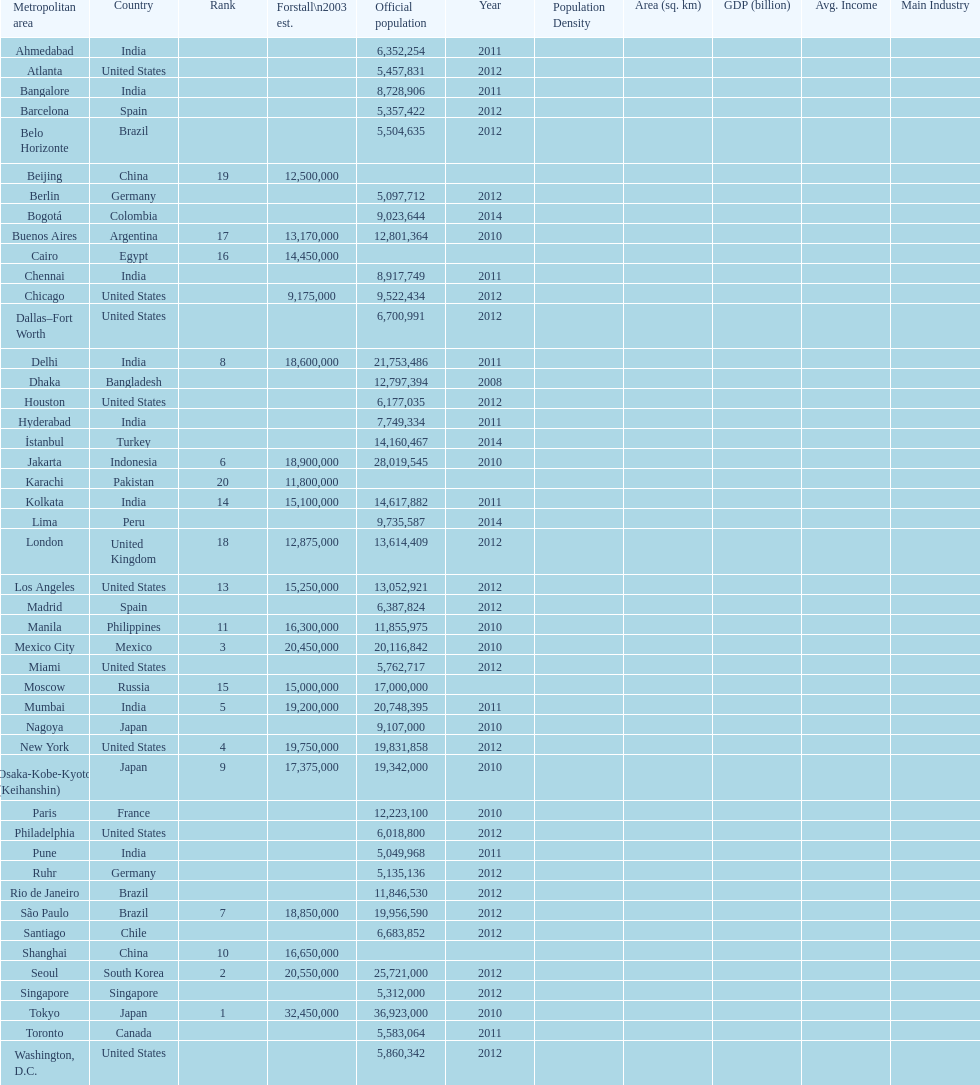Which areas had a population of more than 10,000,000 but less than 20,000,000? Buenos Aires, Dhaka, İstanbul, Kolkata, London, Los Angeles, Manila, Moscow, New York, Osaka-Kobe-Kyoto (Keihanshin), Paris, Rio de Janeiro, São Paulo. 